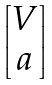Convert formula to latex. <formula><loc_0><loc_0><loc_500><loc_500>\begin{bmatrix} V \\ \L a \end{bmatrix}</formula> 